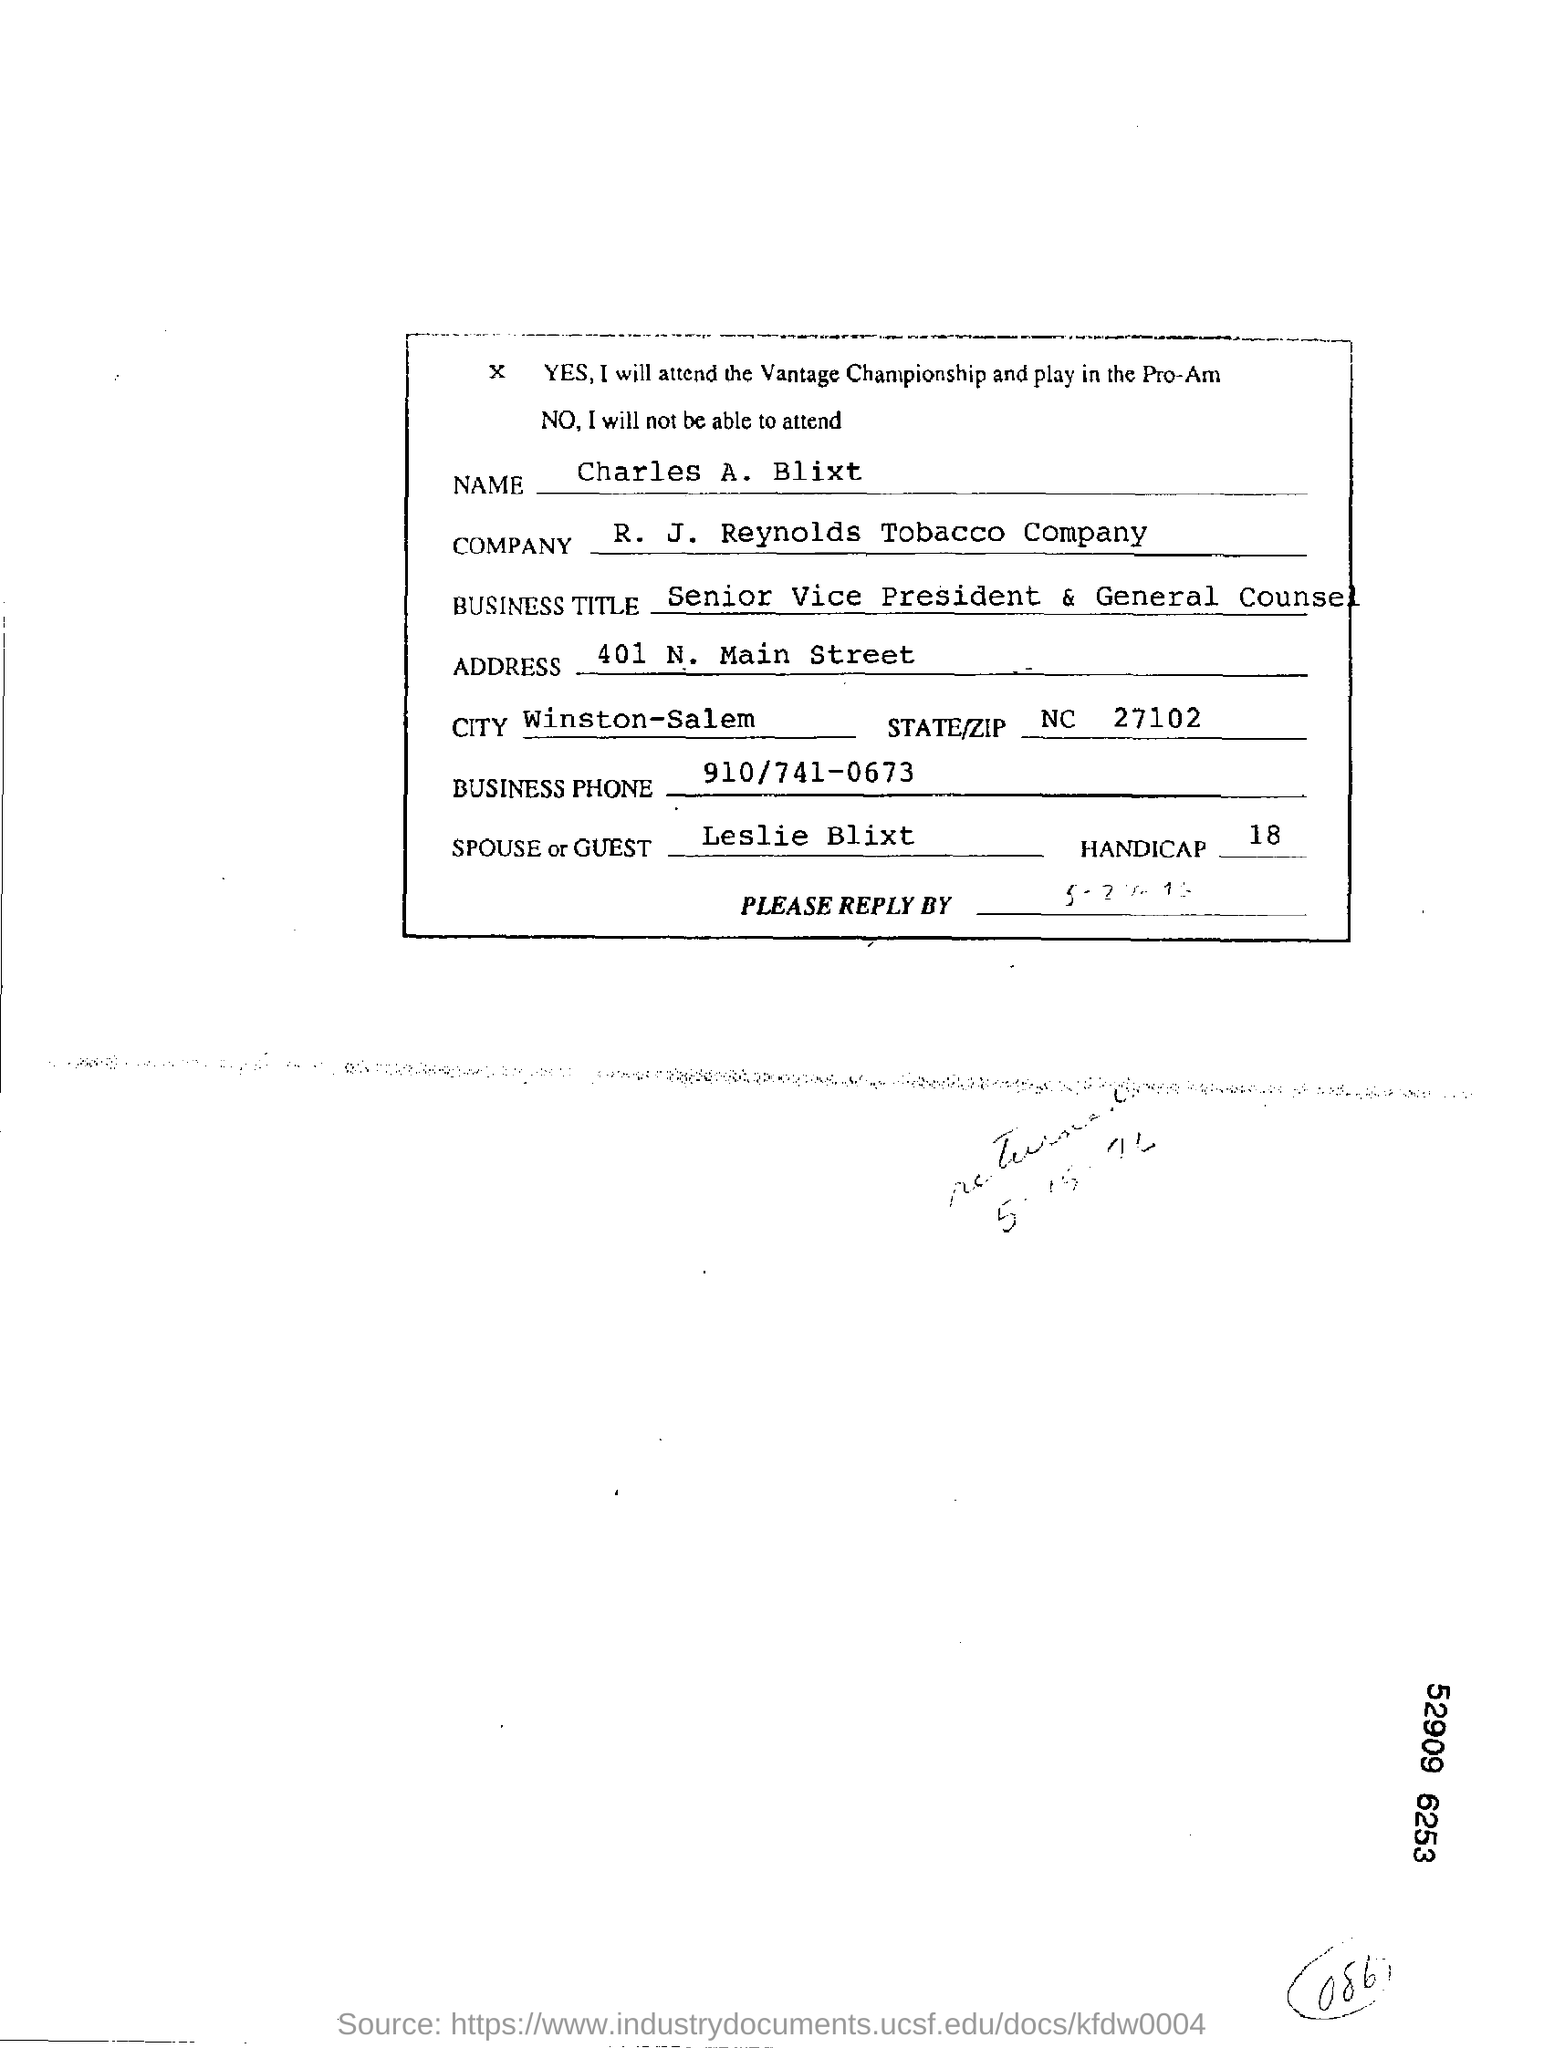Point out several critical features in this image. Charles A. Blixt is a resident of Winston-Salem. The R. J. Reynolds Tobacco Company is mentioned in this document. The state and zip code mentioned in this document are North Carolina 27102. The business phone number, as stated in the document, is 910/741-0673. 